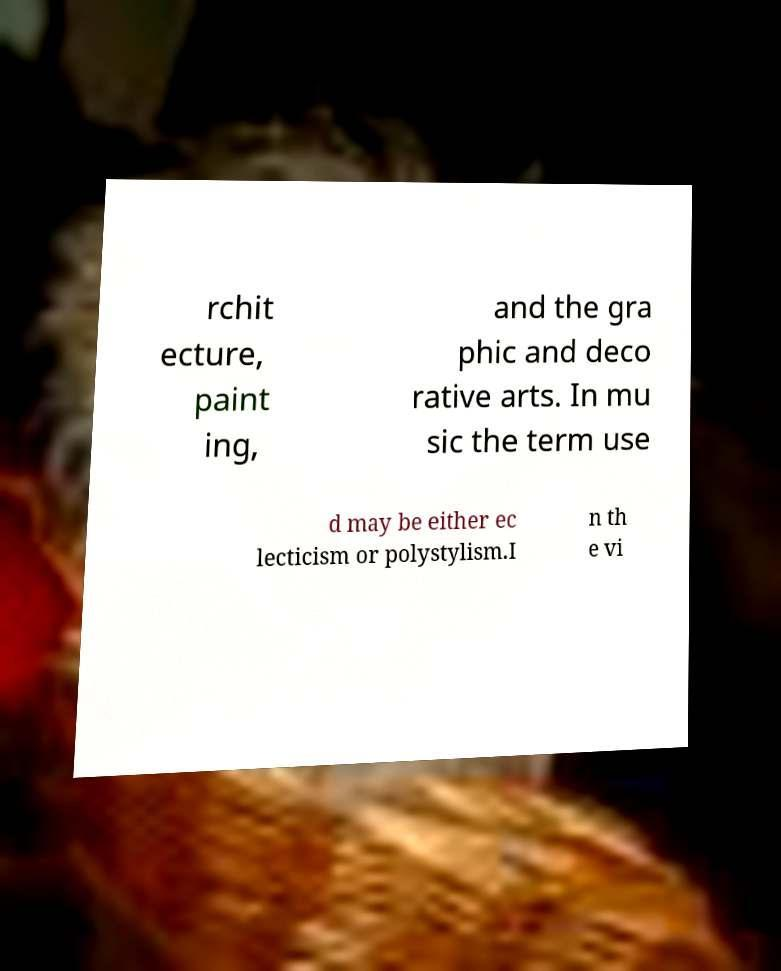For documentation purposes, I need the text within this image transcribed. Could you provide that? rchit ecture, paint ing, and the gra phic and deco rative arts. In mu sic the term use d may be either ec lecticism or polystylism.I n th e vi 